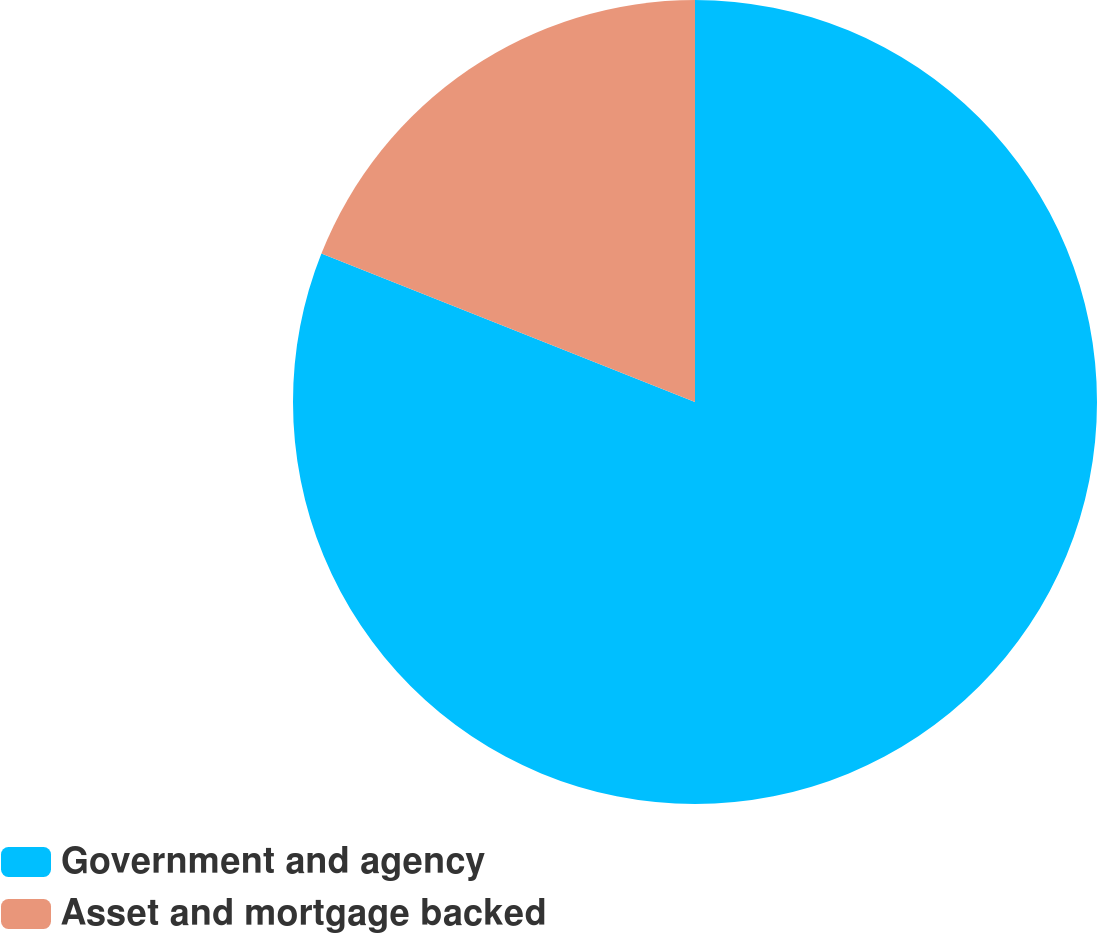Convert chart to OTSL. <chart><loc_0><loc_0><loc_500><loc_500><pie_chart><fcel>Government and agency<fcel>Asset and mortgage backed<nl><fcel>81.02%<fcel>18.98%<nl></chart> 